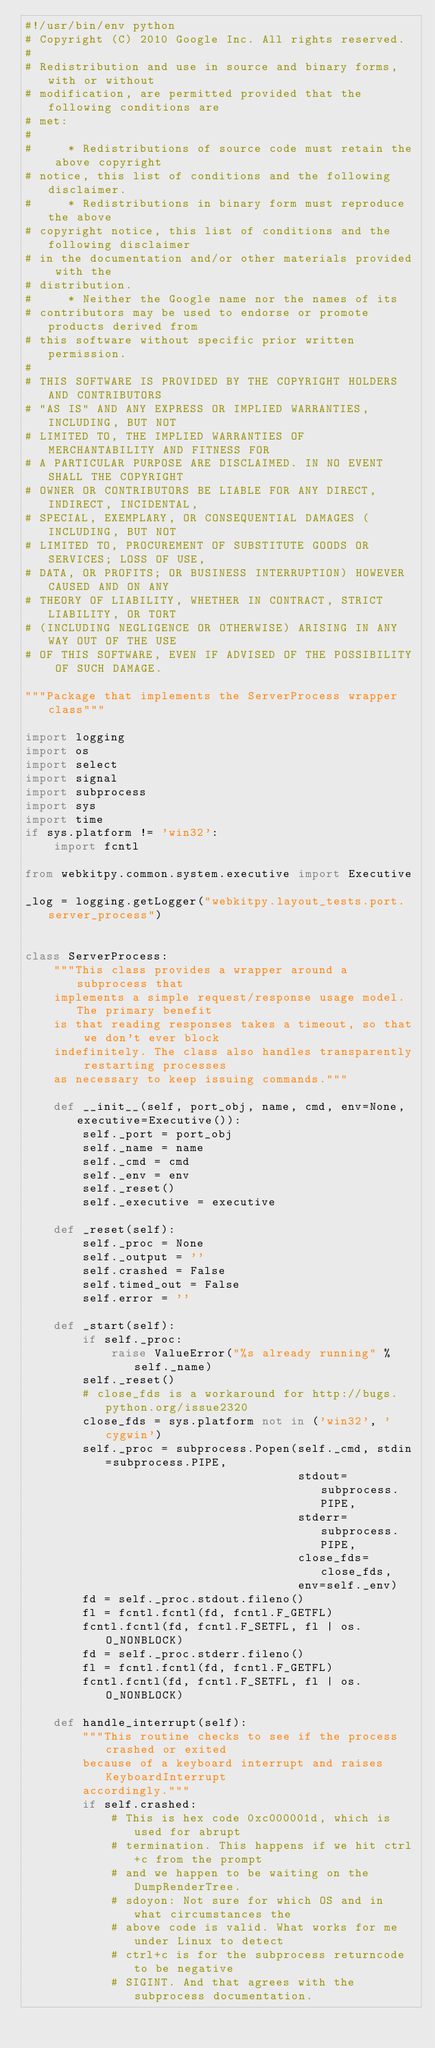Convert code to text. <code><loc_0><loc_0><loc_500><loc_500><_Python_>#!/usr/bin/env python
# Copyright (C) 2010 Google Inc. All rights reserved.
#
# Redistribution and use in source and binary forms, with or without
# modification, are permitted provided that the following conditions are
# met:
#
#     * Redistributions of source code must retain the above copyright
# notice, this list of conditions and the following disclaimer.
#     * Redistributions in binary form must reproduce the above
# copyright notice, this list of conditions and the following disclaimer
# in the documentation and/or other materials provided with the
# distribution.
#     * Neither the Google name nor the names of its
# contributors may be used to endorse or promote products derived from
# this software without specific prior written permission.
#
# THIS SOFTWARE IS PROVIDED BY THE COPYRIGHT HOLDERS AND CONTRIBUTORS
# "AS IS" AND ANY EXPRESS OR IMPLIED WARRANTIES, INCLUDING, BUT NOT
# LIMITED TO, THE IMPLIED WARRANTIES OF MERCHANTABILITY AND FITNESS FOR
# A PARTICULAR PURPOSE ARE DISCLAIMED. IN NO EVENT SHALL THE COPYRIGHT
# OWNER OR CONTRIBUTORS BE LIABLE FOR ANY DIRECT, INDIRECT, INCIDENTAL,
# SPECIAL, EXEMPLARY, OR CONSEQUENTIAL DAMAGES (INCLUDING, BUT NOT
# LIMITED TO, PROCUREMENT OF SUBSTITUTE GOODS OR SERVICES; LOSS OF USE,
# DATA, OR PROFITS; OR BUSINESS INTERRUPTION) HOWEVER CAUSED AND ON ANY
# THEORY OF LIABILITY, WHETHER IN CONTRACT, STRICT LIABILITY, OR TORT
# (INCLUDING NEGLIGENCE OR OTHERWISE) ARISING IN ANY WAY OUT OF THE USE
# OF THIS SOFTWARE, EVEN IF ADVISED OF THE POSSIBILITY OF SUCH DAMAGE.

"""Package that implements the ServerProcess wrapper class"""

import logging
import os
import select
import signal
import subprocess
import sys
import time
if sys.platform != 'win32':
    import fcntl

from webkitpy.common.system.executive import Executive

_log = logging.getLogger("webkitpy.layout_tests.port.server_process")


class ServerProcess:
    """This class provides a wrapper around a subprocess that
    implements a simple request/response usage model. The primary benefit
    is that reading responses takes a timeout, so that we don't ever block
    indefinitely. The class also handles transparently restarting processes
    as necessary to keep issuing commands."""

    def __init__(self, port_obj, name, cmd, env=None, executive=Executive()):
        self._port = port_obj
        self._name = name
        self._cmd = cmd
        self._env = env
        self._reset()
        self._executive = executive

    def _reset(self):
        self._proc = None
        self._output = ''
        self.crashed = False
        self.timed_out = False
        self.error = ''

    def _start(self):
        if self._proc:
            raise ValueError("%s already running" % self._name)
        self._reset()
        # close_fds is a workaround for http://bugs.python.org/issue2320
        close_fds = sys.platform not in ('win32', 'cygwin')
        self._proc = subprocess.Popen(self._cmd, stdin=subprocess.PIPE,
                                      stdout=subprocess.PIPE,
                                      stderr=subprocess.PIPE,
                                      close_fds=close_fds,
                                      env=self._env)
        fd = self._proc.stdout.fileno()
        fl = fcntl.fcntl(fd, fcntl.F_GETFL)
        fcntl.fcntl(fd, fcntl.F_SETFL, fl | os.O_NONBLOCK)
        fd = self._proc.stderr.fileno()
        fl = fcntl.fcntl(fd, fcntl.F_GETFL)
        fcntl.fcntl(fd, fcntl.F_SETFL, fl | os.O_NONBLOCK)

    def handle_interrupt(self):
        """This routine checks to see if the process crashed or exited
        because of a keyboard interrupt and raises KeyboardInterrupt
        accordingly."""
        if self.crashed:
            # This is hex code 0xc000001d, which is used for abrupt
            # termination. This happens if we hit ctrl+c from the prompt
            # and we happen to be waiting on the DumpRenderTree.
            # sdoyon: Not sure for which OS and in what circumstances the
            # above code is valid. What works for me under Linux to detect
            # ctrl+c is for the subprocess returncode to be negative
            # SIGINT. And that agrees with the subprocess documentation.</code> 